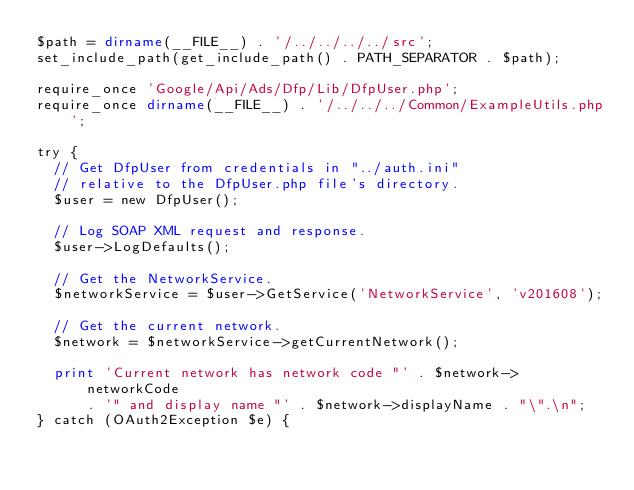Convert code to text. <code><loc_0><loc_0><loc_500><loc_500><_PHP_>$path = dirname(__FILE__) . '/../../../../src';
set_include_path(get_include_path() . PATH_SEPARATOR . $path);

require_once 'Google/Api/Ads/Dfp/Lib/DfpUser.php';
require_once dirname(__FILE__) . '/../../../Common/ExampleUtils.php';

try {
  // Get DfpUser from credentials in "../auth.ini"
  // relative to the DfpUser.php file's directory.
  $user = new DfpUser();

  // Log SOAP XML request and response.
  $user->LogDefaults();

  // Get the NetworkService.
  $networkService = $user->GetService('NetworkService', 'v201608');

  // Get the current network.
  $network = $networkService->getCurrentNetwork();

  print 'Current network has network code "' . $network->networkCode
      . '" and display name "' . $network->displayName . "\".\n";
} catch (OAuth2Exception $e) {</code> 